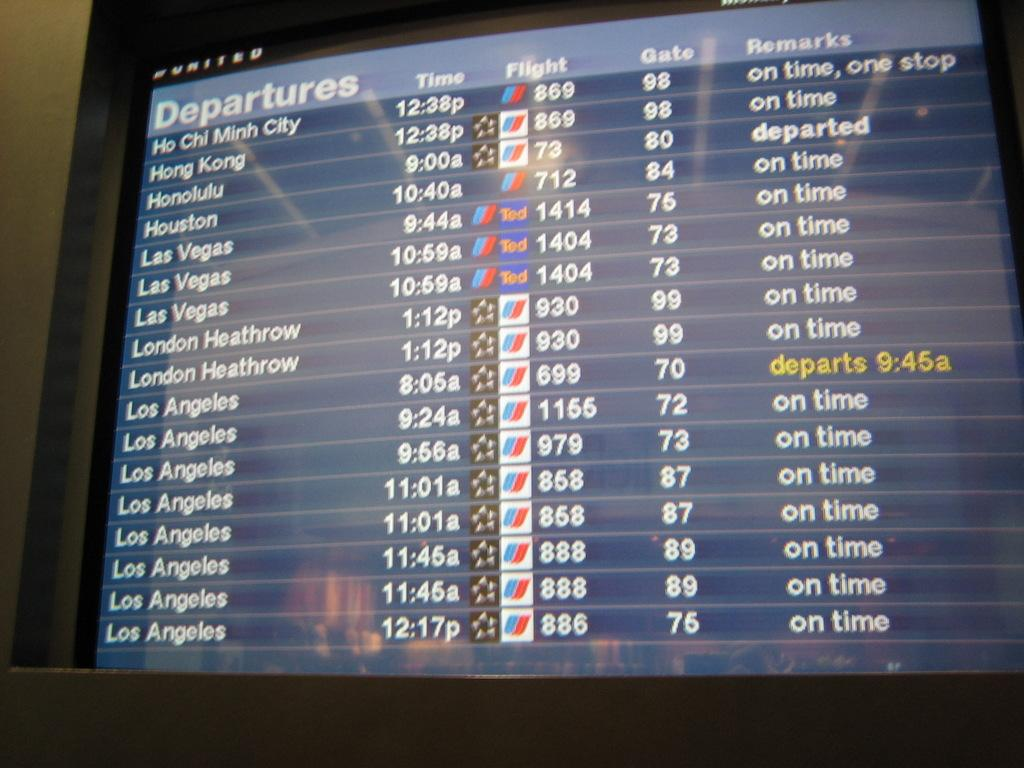<image>
Relay a brief, clear account of the picture shown. a computer screen with the flight departures via Hong Kong, Las Vegas, Los Angeles, and others. 